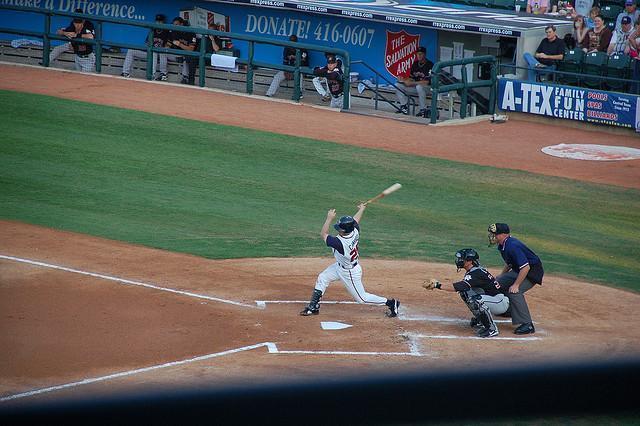Who is the man crouched behind the catcher?
Make your selection and explain in format: 'Answer: answer
Rationale: rationale.'
Options: Umpire, coach, batter, announcer. Answer: umpire.
Rationale: There is an umpire crouched behind the batter. 